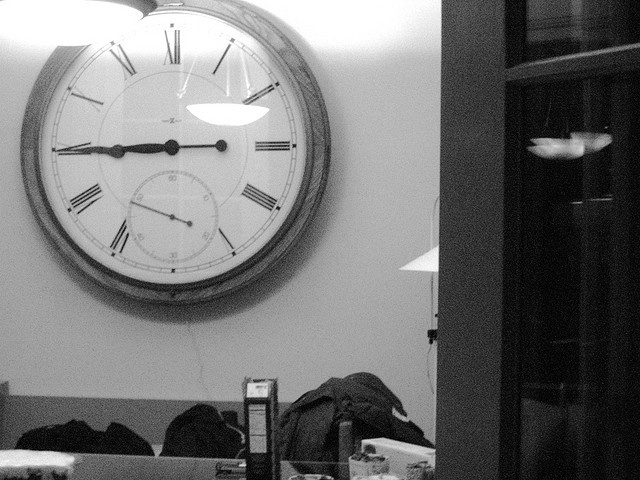Describe the objects in this image and their specific colors. I can see a clock in darkgray, lightgray, gray, and black tones in this image. 